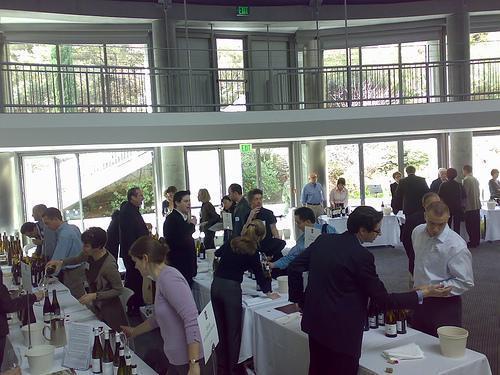How many stories of the building are shown?
Give a very brief answer. 2. How many people are there?
Give a very brief answer. 7. How many dining tables are visible?
Give a very brief answer. 2. 